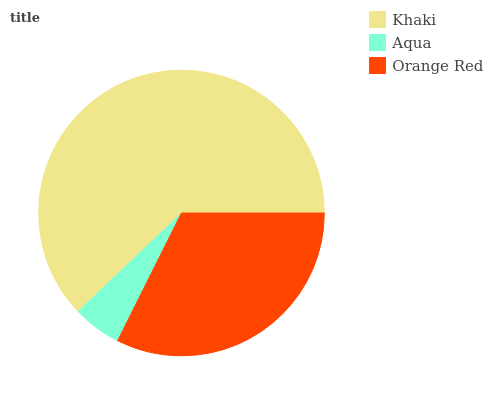Is Aqua the minimum?
Answer yes or no. Yes. Is Khaki the maximum?
Answer yes or no. Yes. Is Orange Red the minimum?
Answer yes or no. No. Is Orange Red the maximum?
Answer yes or no. No. Is Orange Red greater than Aqua?
Answer yes or no. Yes. Is Aqua less than Orange Red?
Answer yes or no. Yes. Is Aqua greater than Orange Red?
Answer yes or no. No. Is Orange Red less than Aqua?
Answer yes or no. No. Is Orange Red the high median?
Answer yes or no. Yes. Is Orange Red the low median?
Answer yes or no. Yes. Is Aqua the high median?
Answer yes or no. No. Is Khaki the low median?
Answer yes or no. No. 